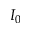Convert formula to latex. <formula><loc_0><loc_0><loc_500><loc_500>I _ { 0 }</formula> 